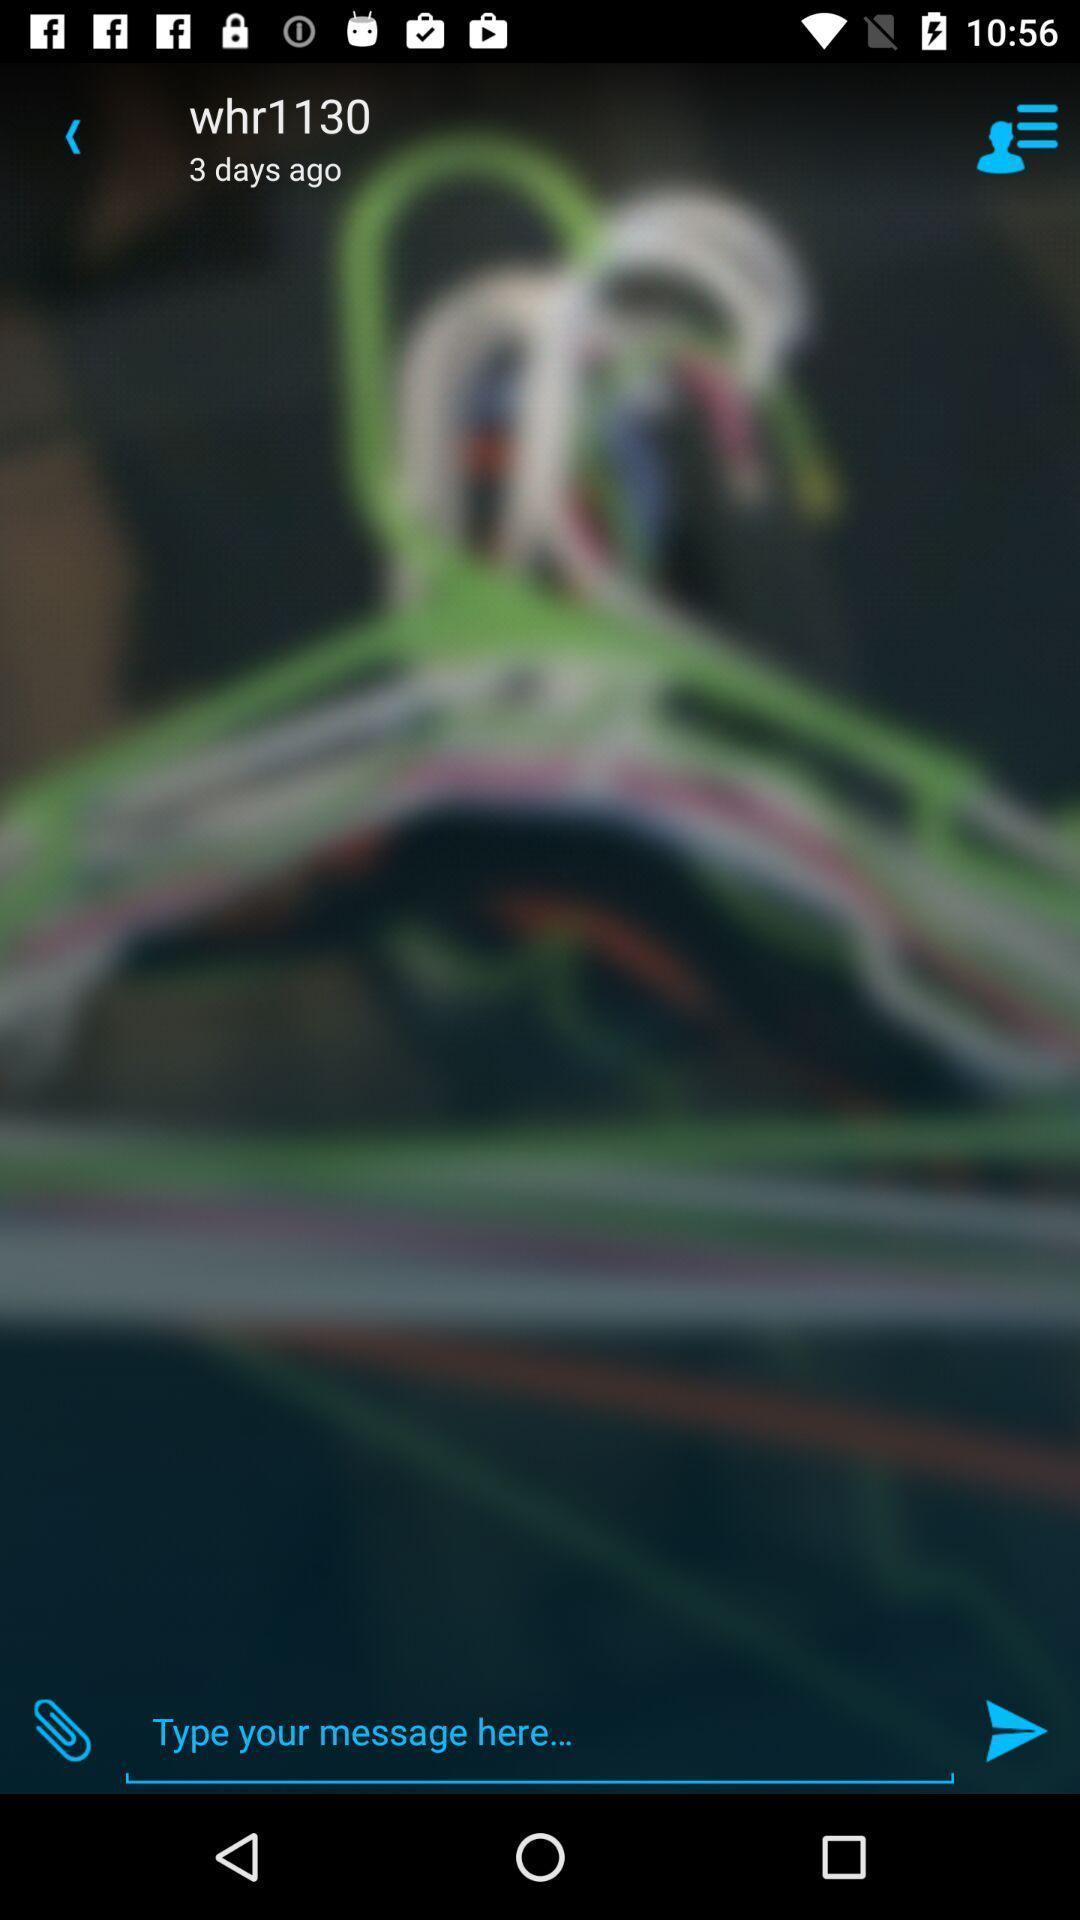Describe the visual elements of this screenshot. Screen displaying the chat box. 